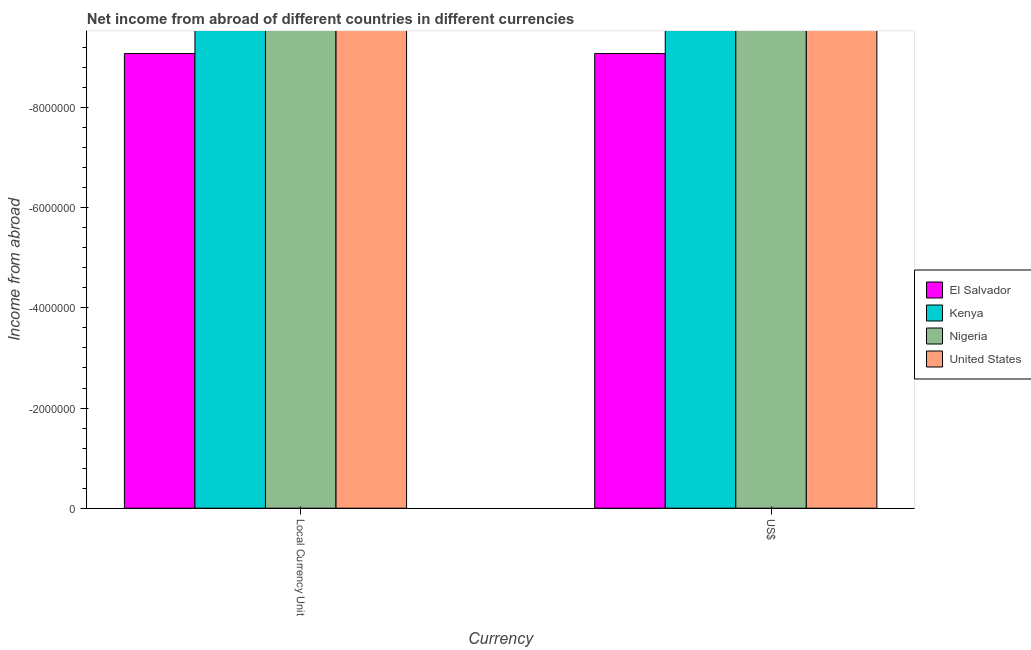How many different coloured bars are there?
Offer a terse response. 0. Are the number of bars on each tick of the X-axis equal?
Your answer should be very brief. Yes. How many bars are there on the 1st tick from the left?
Provide a succinct answer. 0. How many bars are there on the 1st tick from the right?
Ensure brevity in your answer.  0. What is the label of the 2nd group of bars from the left?
Make the answer very short. US$. Across all countries, what is the minimum income from abroad in constant 2005 us$?
Keep it short and to the point. 0. What is the total income from abroad in constant 2005 us$ in the graph?
Your answer should be compact. 0. What is the difference between the income from abroad in us$ in Kenya and the income from abroad in constant 2005 us$ in El Salvador?
Your answer should be very brief. 0. How many bars are there?
Make the answer very short. 0. Are all the bars in the graph horizontal?
Keep it short and to the point. No. Does the graph contain grids?
Offer a very short reply. No. Where does the legend appear in the graph?
Provide a succinct answer. Center right. How many legend labels are there?
Ensure brevity in your answer.  4. What is the title of the graph?
Provide a short and direct response. Net income from abroad of different countries in different currencies. What is the label or title of the X-axis?
Offer a terse response. Currency. What is the label or title of the Y-axis?
Your answer should be compact. Income from abroad. What is the Income from abroad of El Salvador in Local Currency Unit?
Provide a short and direct response. 0. What is the Income from abroad of El Salvador in US$?
Provide a short and direct response. 0. What is the Income from abroad of Nigeria in US$?
Make the answer very short. 0. What is the Income from abroad in United States in US$?
Ensure brevity in your answer.  0. What is the total Income from abroad in Kenya in the graph?
Your answer should be compact. 0. What is the total Income from abroad in Nigeria in the graph?
Your answer should be very brief. 0. What is the average Income from abroad in Nigeria per Currency?
Your response must be concise. 0. What is the average Income from abroad in United States per Currency?
Your answer should be very brief. 0. 